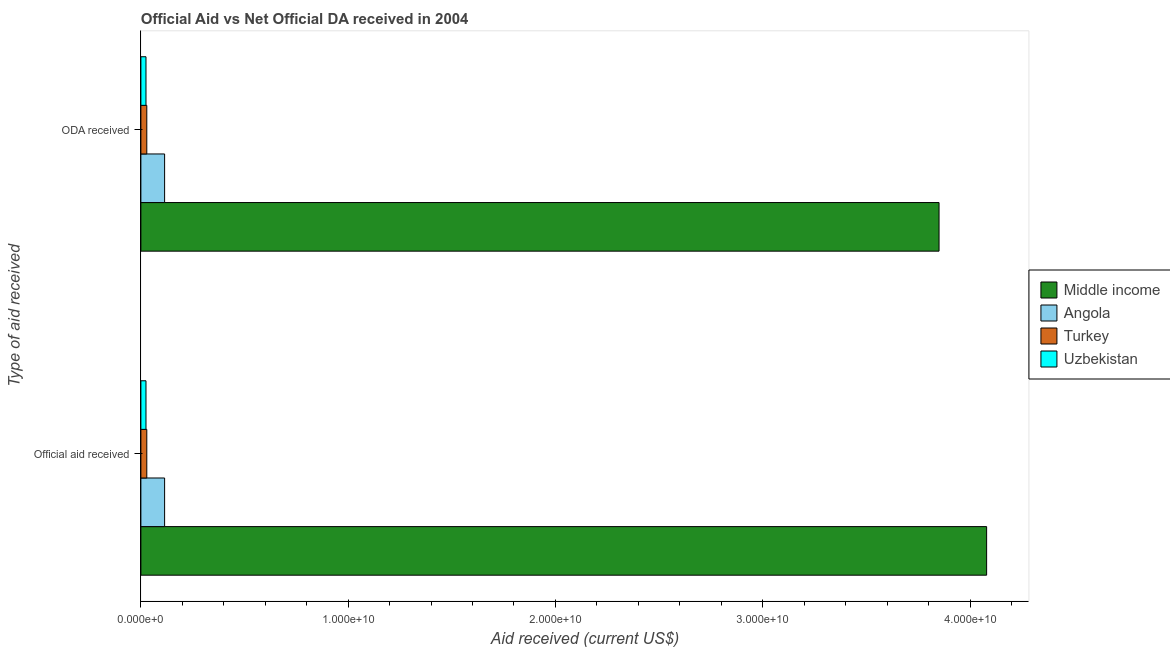How many different coloured bars are there?
Provide a succinct answer. 4. How many groups of bars are there?
Your response must be concise. 2. How many bars are there on the 1st tick from the bottom?
Your response must be concise. 4. What is the label of the 2nd group of bars from the top?
Give a very brief answer. Official aid received. What is the oda received in Angola?
Ensure brevity in your answer.  1.14e+09. Across all countries, what is the maximum oda received?
Offer a terse response. 3.85e+1. Across all countries, what is the minimum oda received?
Offer a terse response. 2.46e+08. In which country was the official aid received maximum?
Your answer should be very brief. Middle income. In which country was the official aid received minimum?
Give a very brief answer. Uzbekistan. What is the total official aid received in the graph?
Provide a short and direct response. 4.25e+1. What is the difference between the oda received in Turkey and that in Angola?
Provide a succinct answer. -8.59e+08. What is the difference between the oda received in Angola and the official aid received in Turkey?
Your response must be concise. 8.59e+08. What is the average official aid received per country?
Provide a succinct answer. 1.06e+1. What is the difference between the official aid received and oda received in Uzbekistan?
Make the answer very short. 0. What is the ratio of the oda received in Uzbekistan to that in Angola?
Your response must be concise. 0.21. Is the oda received in Angola less than that in Middle income?
Offer a terse response. Yes. In how many countries, is the official aid received greater than the average official aid received taken over all countries?
Ensure brevity in your answer.  1. What does the 1st bar from the top in ODA received represents?
Give a very brief answer. Uzbekistan. What does the 2nd bar from the bottom in ODA received represents?
Offer a very short reply. Angola. How many bars are there?
Provide a succinct answer. 8. Are the values on the major ticks of X-axis written in scientific E-notation?
Offer a terse response. Yes. Does the graph contain grids?
Ensure brevity in your answer.  No. How many legend labels are there?
Your answer should be compact. 4. What is the title of the graph?
Make the answer very short. Official Aid vs Net Official DA received in 2004 . Does "Libya" appear as one of the legend labels in the graph?
Your answer should be compact. No. What is the label or title of the X-axis?
Offer a very short reply. Aid received (current US$). What is the label or title of the Y-axis?
Give a very brief answer. Type of aid received. What is the Aid received (current US$) of Middle income in Official aid received?
Offer a very short reply. 4.08e+1. What is the Aid received (current US$) in Angola in Official aid received?
Your response must be concise. 1.14e+09. What is the Aid received (current US$) in Turkey in Official aid received?
Offer a very short reply. 2.85e+08. What is the Aid received (current US$) of Uzbekistan in Official aid received?
Your answer should be compact. 2.46e+08. What is the Aid received (current US$) of Middle income in ODA received?
Make the answer very short. 3.85e+1. What is the Aid received (current US$) of Angola in ODA received?
Make the answer very short. 1.14e+09. What is the Aid received (current US$) in Turkey in ODA received?
Provide a short and direct response. 2.85e+08. What is the Aid received (current US$) of Uzbekistan in ODA received?
Give a very brief answer. 2.46e+08. Across all Type of aid received, what is the maximum Aid received (current US$) of Middle income?
Your response must be concise. 4.08e+1. Across all Type of aid received, what is the maximum Aid received (current US$) of Angola?
Your response must be concise. 1.14e+09. Across all Type of aid received, what is the maximum Aid received (current US$) of Turkey?
Give a very brief answer. 2.85e+08. Across all Type of aid received, what is the maximum Aid received (current US$) of Uzbekistan?
Your answer should be compact. 2.46e+08. Across all Type of aid received, what is the minimum Aid received (current US$) of Middle income?
Ensure brevity in your answer.  3.85e+1. Across all Type of aid received, what is the minimum Aid received (current US$) in Angola?
Keep it short and to the point. 1.14e+09. Across all Type of aid received, what is the minimum Aid received (current US$) of Turkey?
Ensure brevity in your answer.  2.85e+08. Across all Type of aid received, what is the minimum Aid received (current US$) in Uzbekistan?
Give a very brief answer. 2.46e+08. What is the total Aid received (current US$) in Middle income in the graph?
Ensure brevity in your answer.  7.93e+1. What is the total Aid received (current US$) of Angola in the graph?
Keep it short and to the point. 2.29e+09. What is the total Aid received (current US$) of Turkey in the graph?
Offer a terse response. 5.71e+08. What is the total Aid received (current US$) in Uzbekistan in the graph?
Make the answer very short. 4.92e+08. What is the difference between the Aid received (current US$) in Middle income in Official aid received and that in ODA received?
Provide a short and direct response. 2.30e+09. What is the difference between the Aid received (current US$) of Angola in Official aid received and that in ODA received?
Ensure brevity in your answer.  0. What is the difference between the Aid received (current US$) in Middle income in Official aid received and the Aid received (current US$) in Angola in ODA received?
Your response must be concise. 3.97e+1. What is the difference between the Aid received (current US$) of Middle income in Official aid received and the Aid received (current US$) of Turkey in ODA received?
Your response must be concise. 4.05e+1. What is the difference between the Aid received (current US$) of Middle income in Official aid received and the Aid received (current US$) of Uzbekistan in ODA received?
Provide a short and direct response. 4.06e+1. What is the difference between the Aid received (current US$) of Angola in Official aid received and the Aid received (current US$) of Turkey in ODA received?
Keep it short and to the point. 8.59e+08. What is the difference between the Aid received (current US$) in Angola in Official aid received and the Aid received (current US$) in Uzbekistan in ODA received?
Offer a very short reply. 8.99e+08. What is the difference between the Aid received (current US$) of Turkey in Official aid received and the Aid received (current US$) of Uzbekistan in ODA received?
Offer a terse response. 3.94e+07. What is the average Aid received (current US$) in Middle income per Type of aid received?
Provide a succinct answer. 3.97e+1. What is the average Aid received (current US$) of Angola per Type of aid received?
Keep it short and to the point. 1.14e+09. What is the average Aid received (current US$) in Turkey per Type of aid received?
Ensure brevity in your answer.  2.85e+08. What is the average Aid received (current US$) in Uzbekistan per Type of aid received?
Provide a succinct answer. 2.46e+08. What is the difference between the Aid received (current US$) of Middle income and Aid received (current US$) of Angola in Official aid received?
Provide a succinct answer. 3.97e+1. What is the difference between the Aid received (current US$) in Middle income and Aid received (current US$) in Turkey in Official aid received?
Provide a short and direct response. 4.05e+1. What is the difference between the Aid received (current US$) of Middle income and Aid received (current US$) of Uzbekistan in Official aid received?
Your answer should be very brief. 4.06e+1. What is the difference between the Aid received (current US$) in Angola and Aid received (current US$) in Turkey in Official aid received?
Provide a succinct answer. 8.59e+08. What is the difference between the Aid received (current US$) in Angola and Aid received (current US$) in Uzbekistan in Official aid received?
Keep it short and to the point. 8.99e+08. What is the difference between the Aid received (current US$) in Turkey and Aid received (current US$) in Uzbekistan in Official aid received?
Your answer should be compact. 3.94e+07. What is the difference between the Aid received (current US$) of Middle income and Aid received (current US$) of Angola in ODA received?
Keep it short and to the point. 3.74e+1. What is the difference between the Aid received (current US$) in Middle income and Aid received (current US$) in Turkey in ODA received?
Your answer should be very brief. 3.82e+1. What is the difference between the Aid received (current US$) of Middle income and Aid received (current US$) of Uzbekistan in ODA received?
Your answer should be compact. 3.83e+1. What is the difference between the Aid received (current US$) in Angola and Aid received (current US$) in Turkey in ODA received?
Offer a very short reply. 8.59e+08. What is the difference between the Aid received (current US$) in Angola and Aid received (current US$) in Uzbekistan in ODA received?
Keep it short and to the point. 8.99e+08. What is the difference between the Aid received (current US$) in Turkey and Aid received (current US$) in Uzbekistan in ODA received?
Make the answer very short. 3.94e+07. What is the ratio of the Aid received (current US$) in Middle income in Official aid received to that in ODA received?
Your answer should be compact. 1.06. What is the ratio of the Aid received (current US$) of Uzbekistan in Official aid received to that in ODA received?
Provide a succinct answer. 1. What is the difference between the highest and the second highest Aid received (current US$) in Middle income?
Give a very brief answer. 2.30e+09. What is the difference between the highest and the second highest Aid received (current US$) in Angola?
Offer a terse response. 0. What is the difference between the highest and the second highest Aid received (current US$) of Turkey?
Keep it short and to the point. 0. What is the difference between the highest and the second highest Aid received (current US$) in Uzbekistan?
Offer a terse response. 0. What is the difference between the highest and the lowest Aid received (current US$) of Middle income?
Offer a terse response. 2.30e+09. What is the difference between the highest and the lowest Aid received (current US$) in Turkey?
Ensure brevity in your answer.  0. 